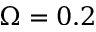<formula> <loc_0><loc_0><loc_500><loc_500>\Omega = 0 . 2</formula> 